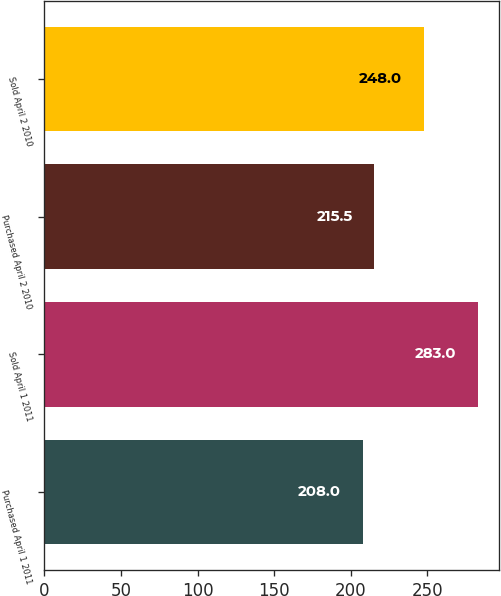Convert chart. <chart><loc_0><loc_0><loc_500><loc_500><bar_chart><fcel>Purchased April 1 2011<fcel>Sold April 1 2011<fcel>Purchased April 2 2010<fcel>Sold April 2 2010<nl><fcel>208<fcel>283<fcel>215.5<fcel>248<nl></chart> 